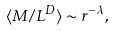Convert formula to latex. <formula><loc_0><loc_0><loc_500><loc_500>\langle M / L ^ { D } \rangle \sim r ^ { - \lambda } ,</formula> 